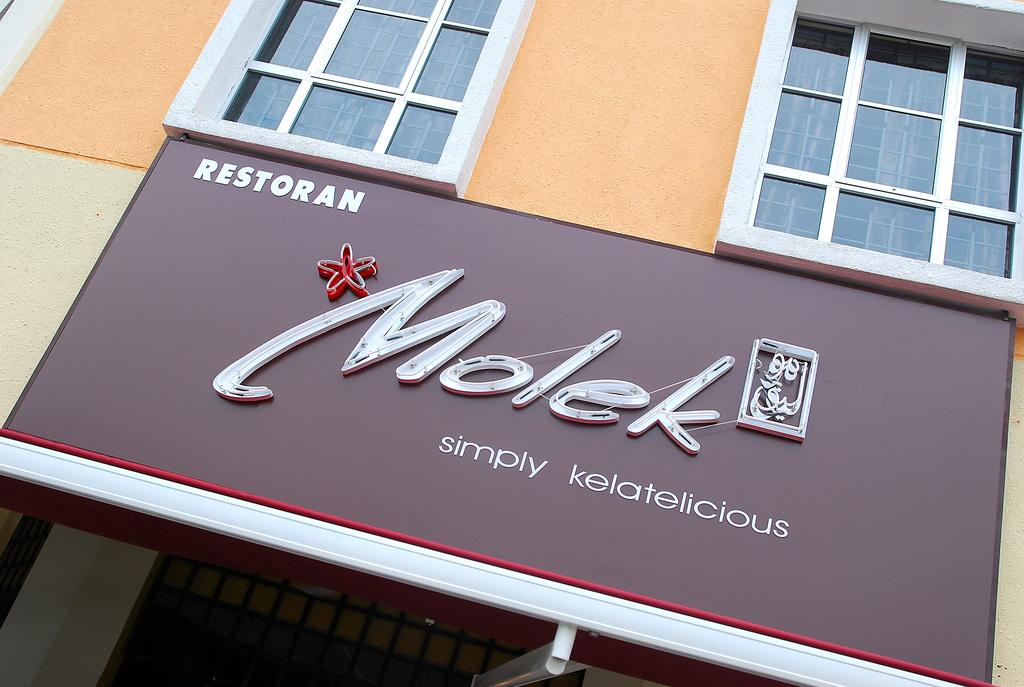What type of structure is visible in the image? There is a building in the image. What feature can be seen on the building? The building has windows. Is there any signage or advertisement on the building? Yes, there is a hoarding on the building. What is written on the hoarding? The hoarding has the word "Molek" written on it. How many cars are parked in front of the hospital in the image? There is no hospital or cars present in the image; it features a building with a hoarding. 